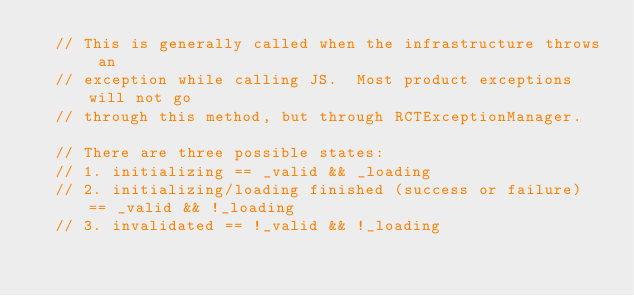Convert code to text. <code><loc_0><loc_0><loc_500><loc_500><_ObjectiveC_>  // This is generally called when the infrastructure throws an
  // exception while calling JS.  Most product exceptions will not go
  // through this method, but through RCTExceptionManager.

  // There are three possible states:
  // 1. initializing == _valid && _loading
  // 2. initializing/loading finished (success or failure) == _valid && !_loading
  // 3. invalidated == !_valid && !_loading
</code> 